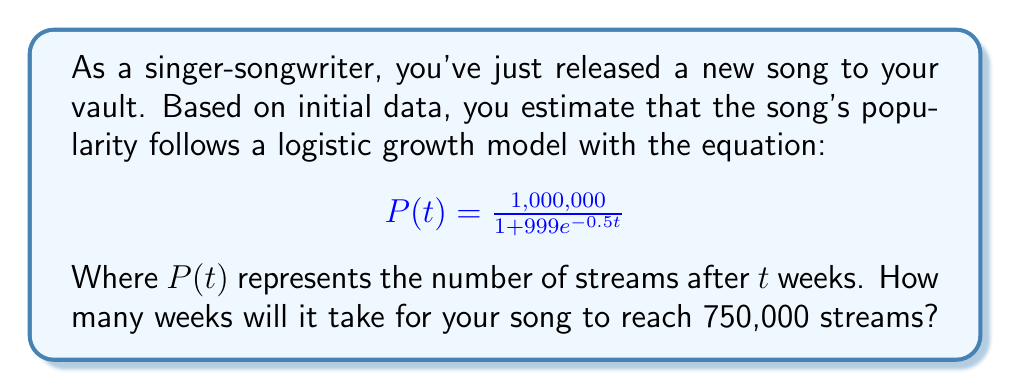What is the answer to this math problem? To solve this problem, we need to follow these steps:

1) The logistic growth model is given by:

   $$P(t) = \frac{1,000,000}{1 + 999e^{-0.5t}}$$

2) We want to find $t$ when $P(t) = 750,000$. So, let's set up the equation:

   $$750,000 = \frac{1,000,000}{1 + 999e^{-0.5t}}$$

3) Multiply both sides by $(1 + 999e^{-0.5t})$:

   $$750,000(1 + 999e^{-0.5t}) = 1,000,000$$

4) Expand the left side:

   $$750,000 + 749,250,000e^{-0.5t} = 1,000,000$$

5) Subtract 750,000 from both sides:

   $$749,250,000e^{-0.5t} = 250,000$$

6) Divide both sides by 749,250,000:

   $$e^{-0.5t} = \frac{1}{2,997}$$

7) Take the natural log of both sides:

   $$-0.5t = \ln(\frac{1}{2,997}) = -\ln(2,997)$$

8) Divide both sides by -0.5:

   $$t = \frac{\ln(2,997)}{0.5} \approx 16.01$$

Therefore, it will take approximately 16 weeks for the song to reach 750,000 streams.
Answer: 16 weeks 